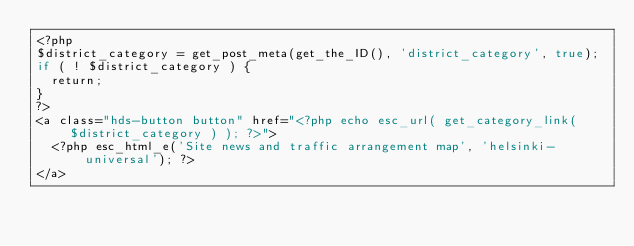<code> <loc_0><loc_0><loc_500><loc_500><_PHP_><?php
$district_category = get_post_meta(get_the_ID(), 'district_category', true);
if ( ! $district_category ) {
	return;
}
?>
<a class="hds-button button" href="<?php echo esc_url( get_category_link( $district_category ) ); ?>">
	<?php esc_html_e('Site news and traffic arrangement map', 'helsinki-universal'); ?>
</a>
</code> 